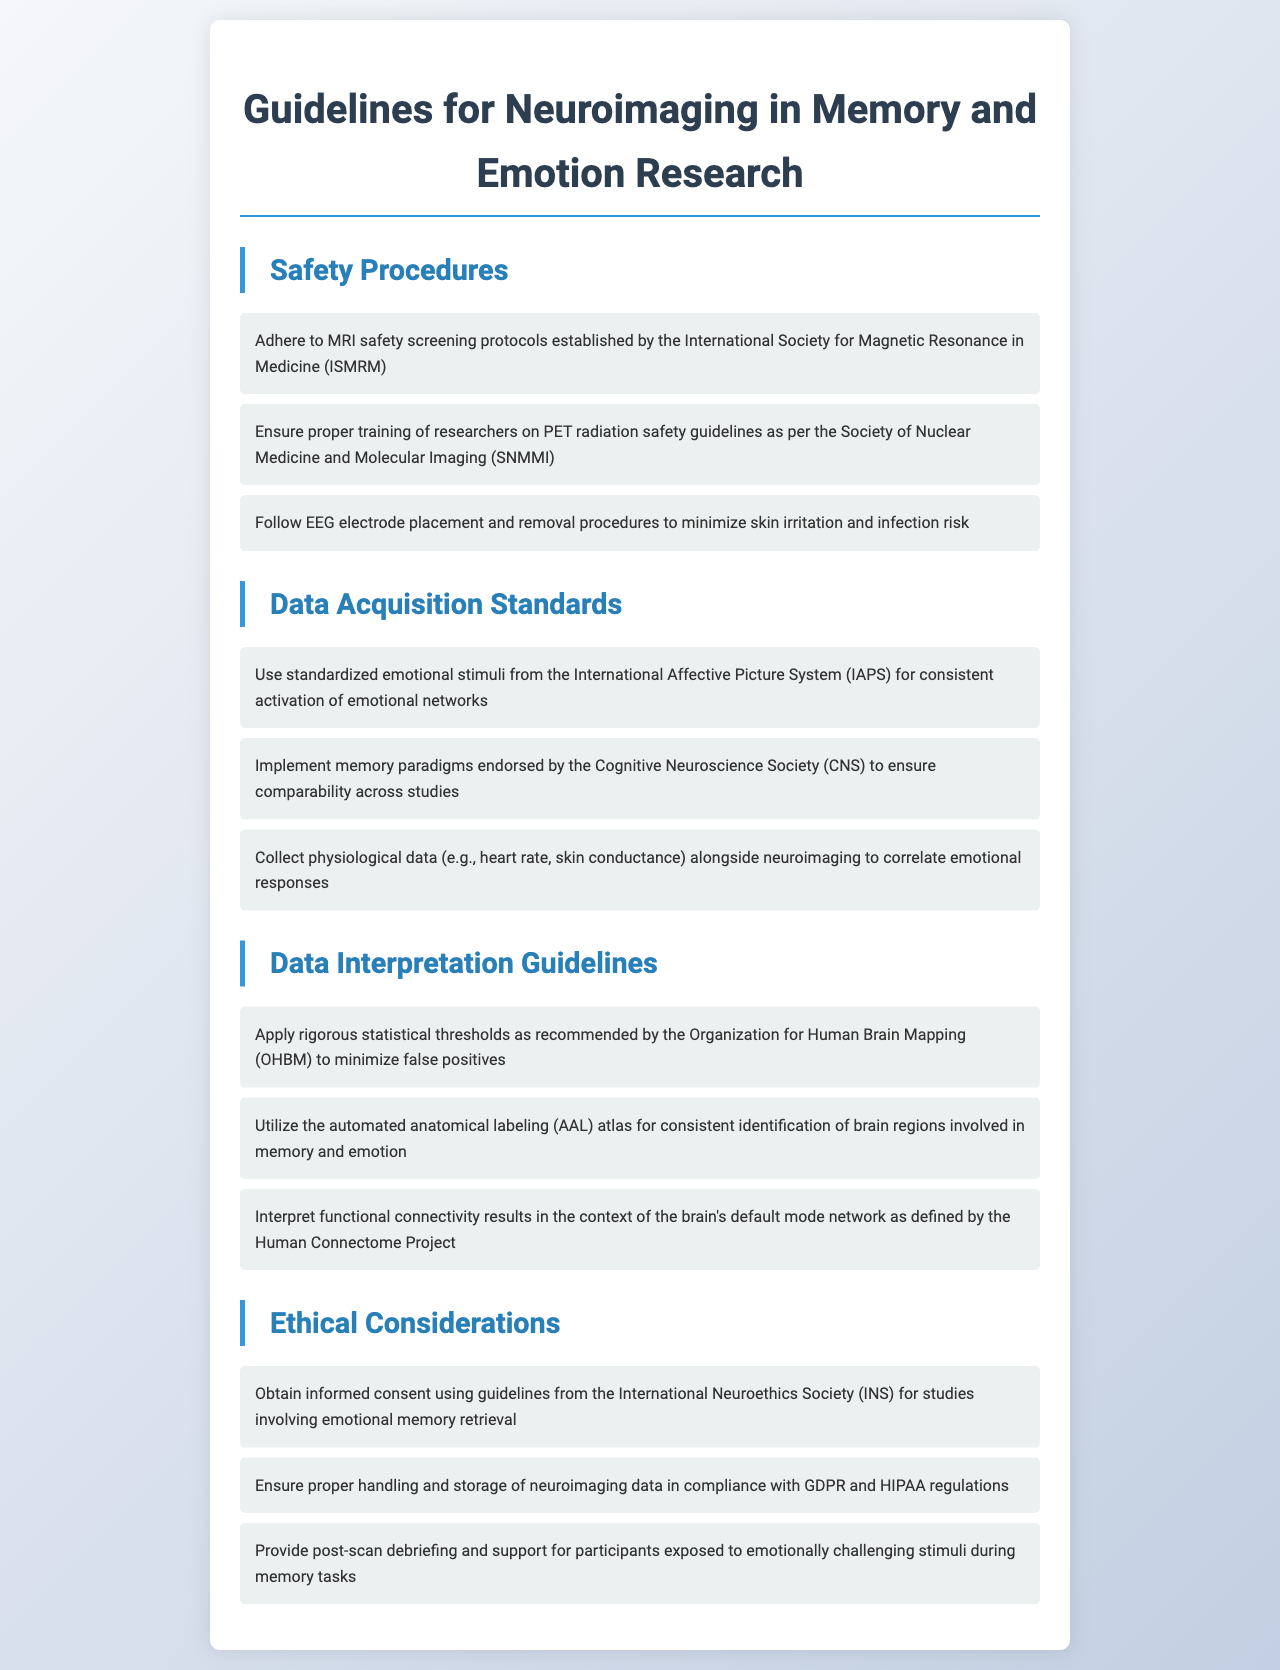What are the safety screening protocols to follow? The document specifies to adhere to MRI safety screening protocols established by the International Society for Magnetic Resonance in Medicine (ISMRM).
Answer: MRI safety screening protocols What organization provides guidelines for PET radiation safety? The Society of Nuclear Medicine and Molecular Imaging (SNMMI) is mentioned as the source for PET radiation safety guidelines.
Answer: Society of Nuclear Medicine and Molecular Imaging What type of stimuli should be used for emotional activation? The document recommends using standardized emotional stimuli from the International Affective Picture System (IAPS).
Answer: International Affective Picture System What is one ethical consideration mentioned? The document states that obtaining informed consent is crucial, following guidelines from the International Neuroethics Society (INS).
Answer: Informed consent What statistical thresholds should be applied? The document advises applying rigorous statistical thresholds as recommended by the Organization for Human Brain Mapping (OHBM).
Answer: Organization for Human Brain Mapping How many safety procedures are listed? There are three safety procedures outlined in the document.
Answer: Three What type of data should be collected alongside neuroimaging? Physiological data, such as heart rate and skin conductance, should be collected alongside neuroimaging data.
Answer: Physiological data Which atlas is recommended for identifying brain regions? The automated anatomical labeling (AAL) atlas is recommended for consistent identification of brain regions.
Answer: AAL atlas 